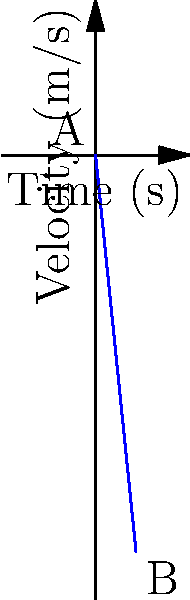The velocity-time graph of an object in free fall is shown above. What is the acceleration of the object during its fall? Let's approach this step-by-step:

1) In a velocity-time graph, acceleration is represented by the slope of the line.

2) The slope of a straight line is given by the formula:

   $$ \text{slope} = \frac{\text{change in y}}{\text{change in x}} = \frac{\Delta v}{\Delta t} $$

3) Let's choose two points on the line:
   Point A: $(0, 0)$
   Point B: $(5, -49)$

4) Now, let's calculate the slope:

   $$ \text{slope} = \frac{v_B - v_A}{t_B - t_A} = \frac{-49 - 0}{5 - 0} = \frac{-49}{5} = -9.8 $$

5) The units for this slope are $\frac{m/s}{s}$ or $m/s^2$, which are the units for acceleration.

6) The negative sign indicates that the velocity is decreasing over time, which is consistent with an object falling towards the Earth (in the negative direction).

Therefore, the acceleration of the object is $-9.8 m/s^2$, which is equal to the acceleration due to gravity on Earth.
Answer: $-9.8 \text{ m/s}^2$ 